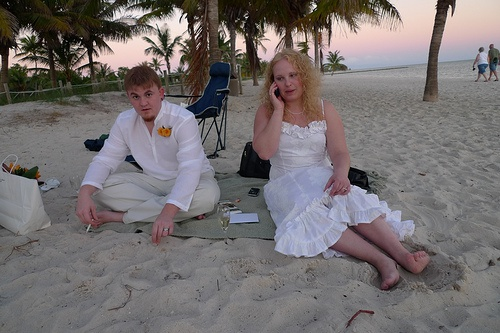Describe the objects in this image and their specific colors. I can see people in black, darkgray, and gray tones, people in black, darkgray, gray, and brown tones, handbag in black and gray tones, chair in black and gray tones, and handbag in black and gray tones in this image. 